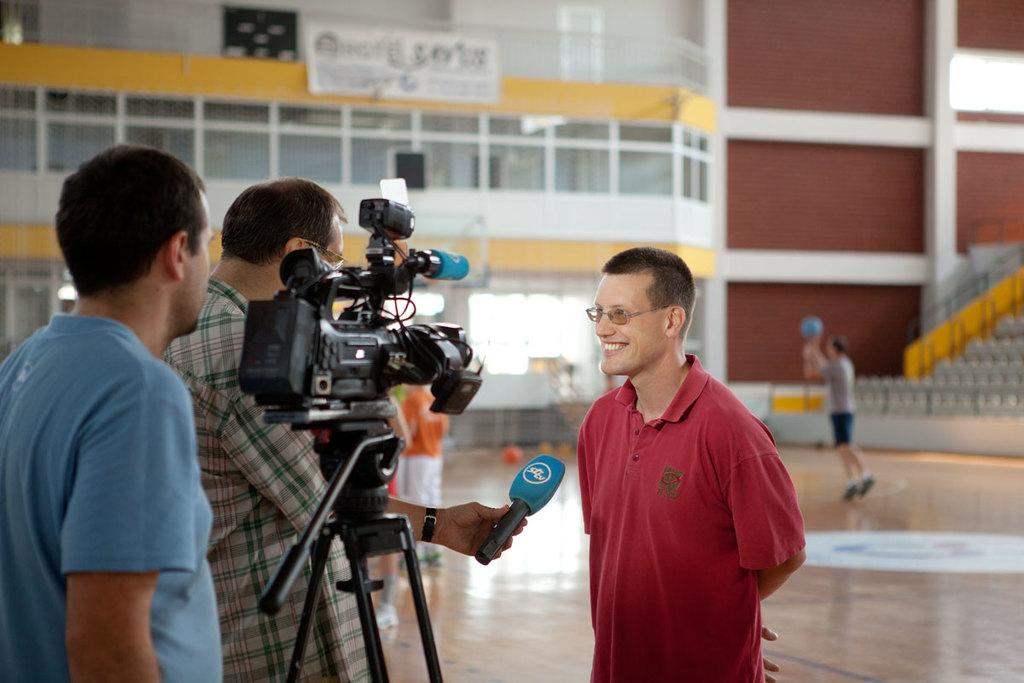What is the person in the image doing? The person is standing in front of a microphone. Who is the person looking at? The person is looking at someone. What can be seen on the right side of the image? There are two people standing with a video recorder on the right side. What force is causing the sea to rise in the image? There is no sea present in the image, so there is no force causing the sea to rise. 